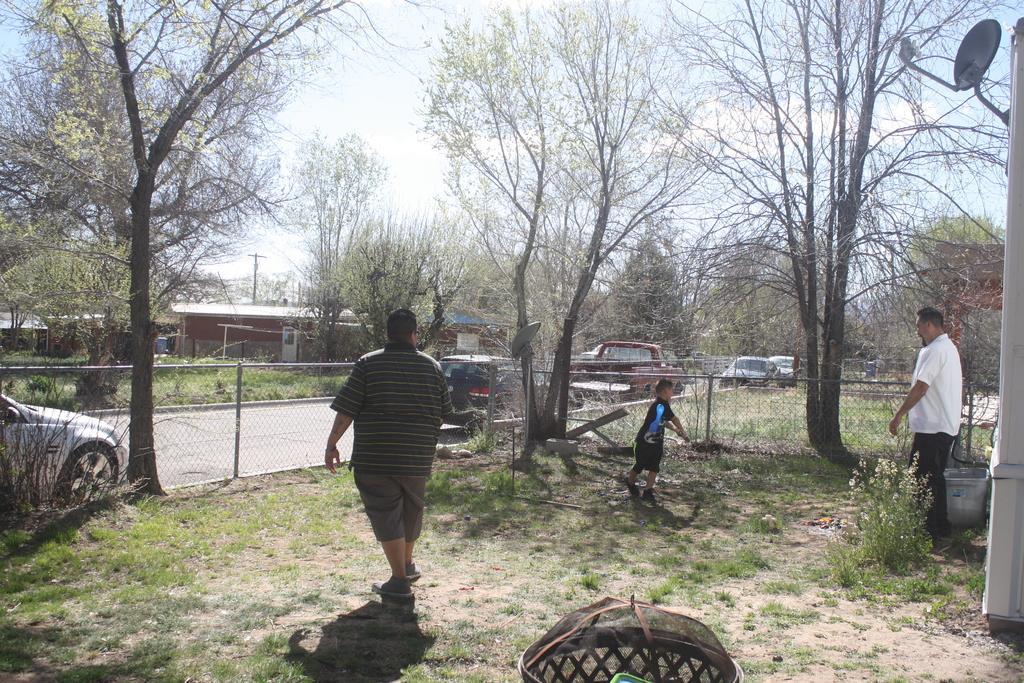How would you summarize this image in a sentence or two? In this picture we can see three persons, at the bottom there is grass, on the left side we can see fencing, there are some vehicles in the middle, in the background there are some trees, a shed, plants and a pole, on the right side we can see a satellite dish, there is the sky at the top of the picture. 